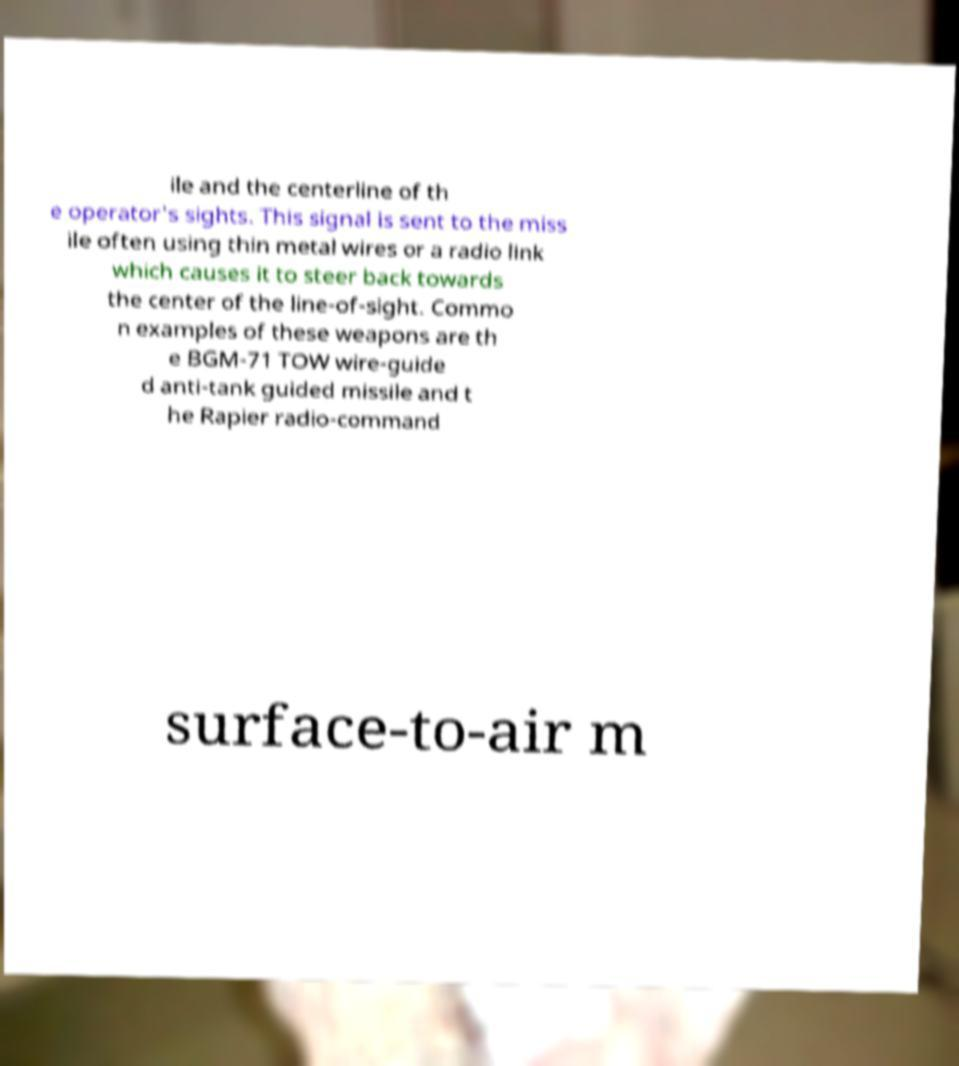Can you accurately transcribe the text from the provided image for me? ile and the centerline of th e operator's sights. This signal is sent to the miss ile often using thin metal wires or a radio link which causes it to steer back towards the center of the line-of-sight. Commo n examples of these weapons are th e BGM-71 TOW wire-guide d anti-tank guided missile and t he Rapier radio-command surface-to-air m 